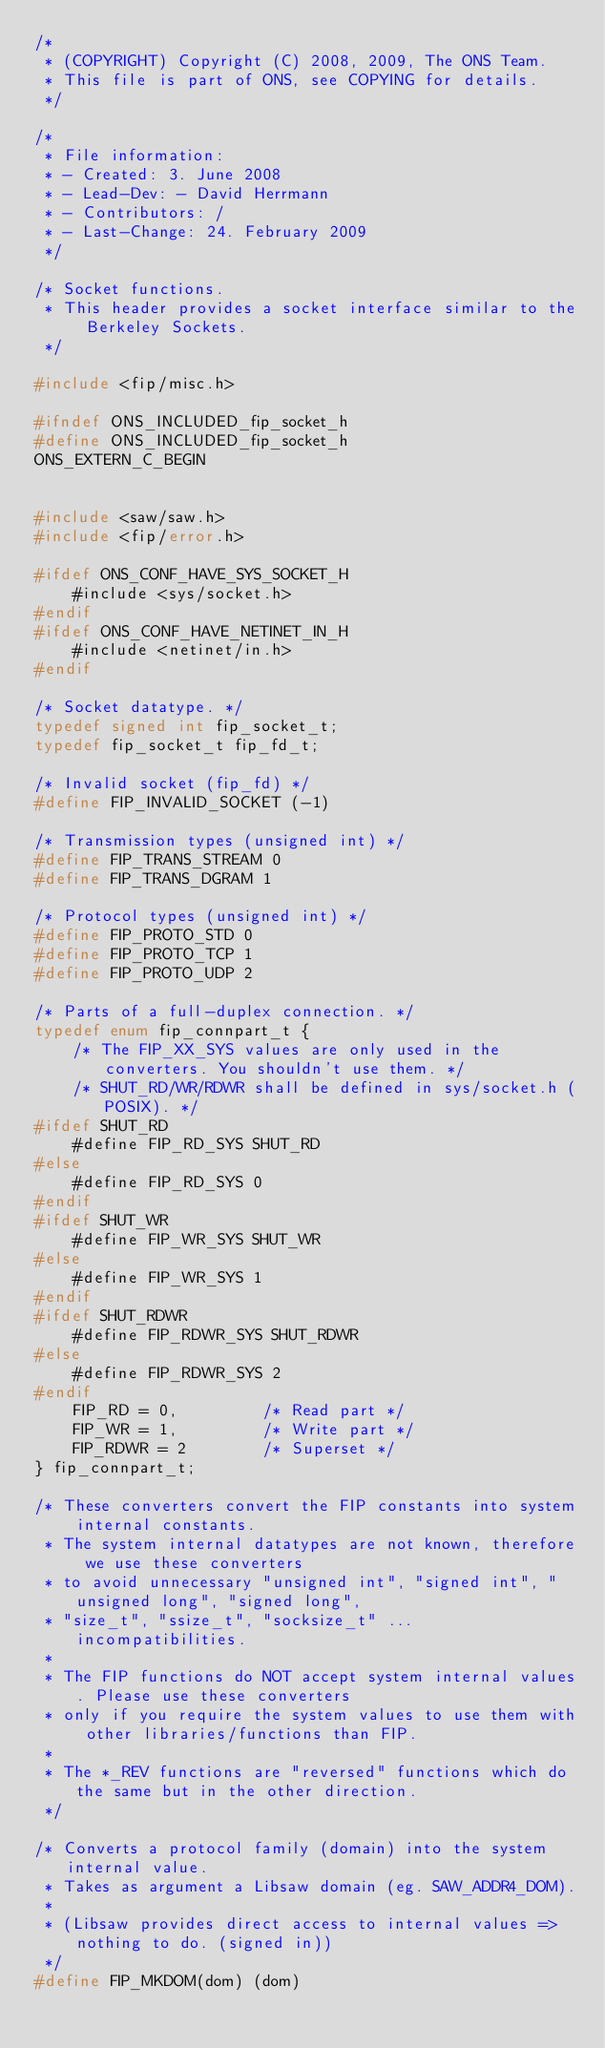Convert code to text. <code><loc_0><loc_0><loc_500><loc_500><_C_>/*
 * (COPYRIGHT) Copyright (C) 2008, 2009, The ONS Team.
 * This file is part of ONS, see COPYING for details.
 */

/*
 * File information:
 * - Created: 3. June 2008
 * - Lead-Dev: - David Herrmann
 * - Contributors: /
 * - Last-Change: 24. February 2009
 */

/* Socket functions.
 * This header provides a socket interface similar to the Berkeley Sockets.
 */

#include <fip/misc.h>

#ifndef ONS_INCLUDED_fip_socket_h
#define ONS_INCLUDED_fip_socket_h
ONS_EXTERN_C_BEGIN


#include <saw/saw.h>
#include <fip/error.h>

#ifdef ONS_CONF_HAVE_SYS_SOCKET_H
    #include <sys/socket.h>
#endif
#ifdef ONS_CONF_HAVE_NETINET_IN_H
    #include <netinet/in.h>
#endif

/* Socket datatype. */
typedef signed int fip_socket_t;
typedef fip_socket_t fip_fd_t;

/* Invalid socket (fip_fd) */
#define FIP_INVALID_SOCKET (-1)

/* Transmission types (unsigned int) */
#define FIP_TRANS_STREAM 0
#define FIP_TRANS_DGRAM 1

/* Protocol types (unsigned int) */
#define FIP_PROTO_STD 0
#define FIP_PROTO_TCP 1
#define FIP_PROTO_UDP 2

/* Parts of a full-duplex connection. */
typedef enum fip_connpart_t {
    /* The FIP_XX_SYS values are only used in the converters. You shouldn't use them. */
    /* SHUT_RD/WR/RDWR shall be defined in sys/socket.h (POSIX). */
#ifdef SHUT_RD
    #define FIP_RD_SYS SHUT_RD
#else
    #define FIP_RD_SYS 0
#endif
#ifdef SHUT_WR
    #define FIP_WR_SYS SHUT_WR
#else
    #define FIP_WR_SYS 1
#endif
#ifdef SHUT_RDWR
    #define FIP_RDWR_SYS SHUT_RDWR
#else
    #define FIP_RDWR_SYS 2
#endif
    FIP_RD = 0,         /* Read part */
    FIP_WR = 1,         /* Write part */
    FIP_RDWR = 2        /* Superset */
} fip_connpart_t;

/* These converters convert the FIP constants into system internal constants.
 * The system internal datatypes are not known, therefore we use these converters
 * to avoid unnecessary "unsigned int", "signed int", "unsigned long", "signed long",
 * "size_t", "ssize_t", "socksize_t" ... incompatibilities.
 *
 * The FIP functions do NOT accept system internal values. Please use these converters
 * only if you require the system values to use them with other libraries/functions than FIP.
 *
 * The *_REV functions are "reversed" functions which do the same but in the other direction.
 */

/* Converts a protocol family (domain) into the system internal value.
 * Takes as argument a Libsaw domain (eg. SAW_ADDR4_DOM).
 *
 * (Libsaw provides direct access to internal values => nothing to do. (signed in))
 */
#define FIP_MKDOM(dom) (dom)</code> 